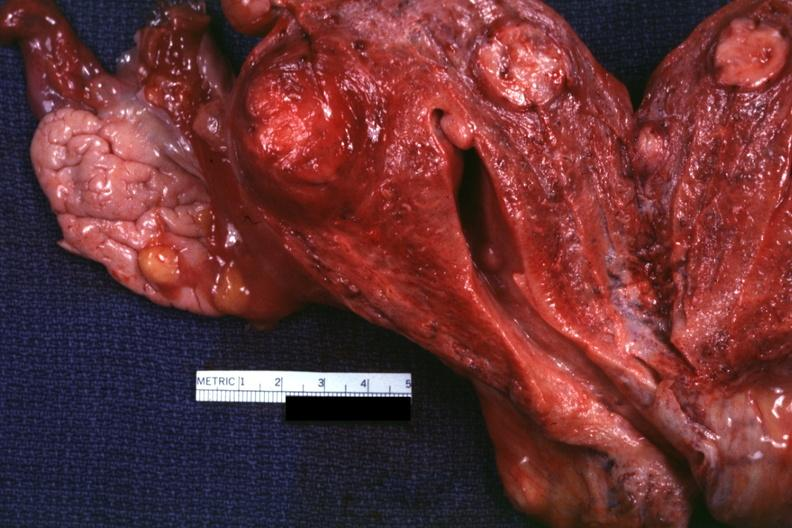where does this part belong to?
Answer the question using a single word or phrase. Female reproductive system 